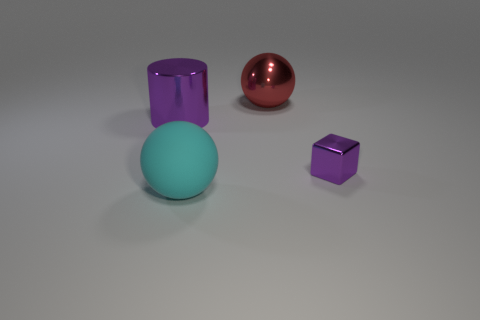Add 4 red shiny cylinders. How many objects exist? 8 Subtract all cubes. How many objects are left? 3 Add 3 big balls. How many big balls are left? 5 Add 4 green shiny cubes. How many green shiny cubes exist? 4 Subtract 0 blue cubes. How many objects are left? 4 Subtract all tiny purple cubes. Subtract all small cyan spheres. How many objects are left? 3 